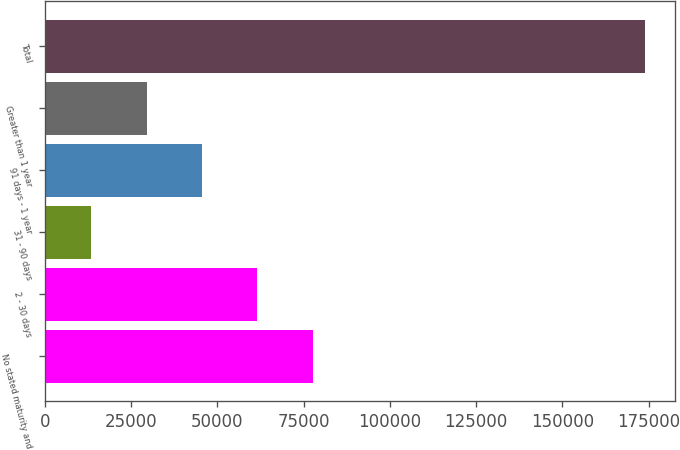<chart> <loc_0><loc_0><loc_500><loc_500><bar_chart><fcel>No stated maturity and<fcel>2 - 30 days<fcel>31 - 90 days<fcel>91 days - 1 year<fcel>Greater than 1 year<fcel>Total<nl><fcel>77640.6<fcel>61602.7<fcel>13489<fcel>45564.8<fcel>29526.9<fcel>173868<nl></chart> 